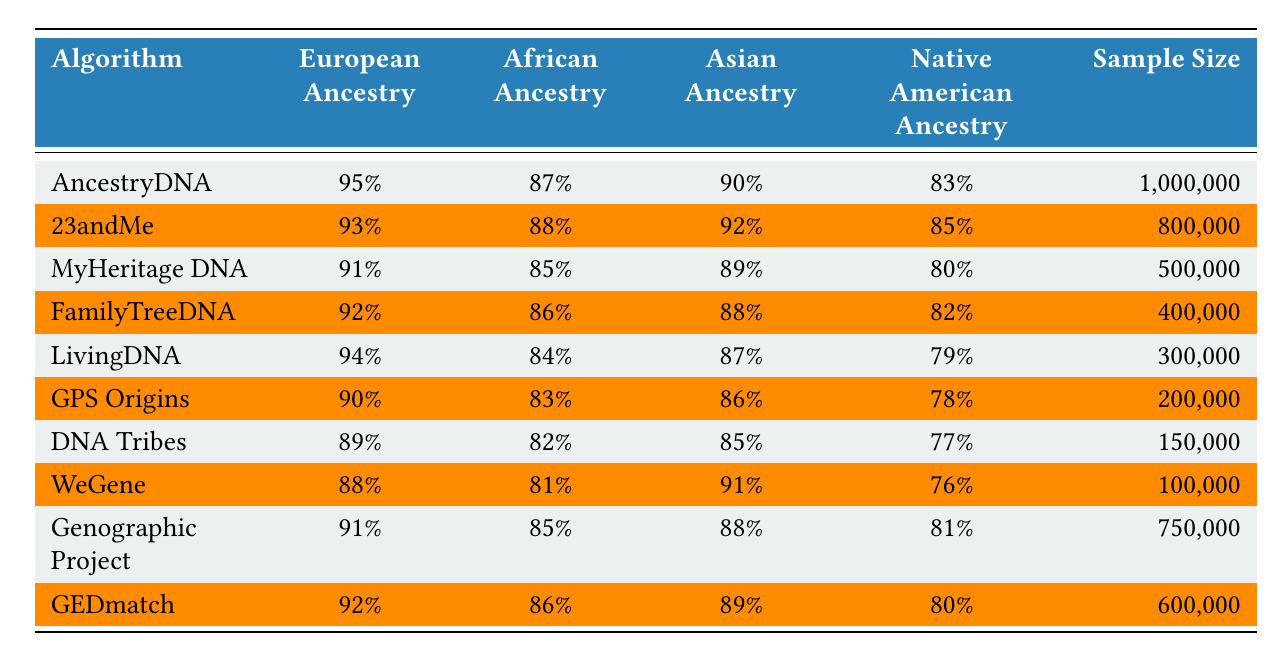What is the highest accuracy for European ancestry among the algorithms? The table lists the accuracy for European ancestry for each algorithm. The highest value is found under AncestryDNA, which has an accuracy of 95%.
Answer: 95% Which algorithm shows the lowest accuracy for African ancestry? By looking at the African ancestry accuracy values, DNA Tribes has the lowest accuracy at 82%.
Answer: 82% What is the average accuracy for Asian ancestry across all algorithms? To find the average accuracy for Asian ancestry, add all the percentages (90+92+89+88+87+86+85+91+88+89 = 885) and divide by the number of algorithms (10). 885 / 10 = 88.5%.
Answer: 88.5% Is the accuracy for Native American ancestry higher for 23andMe than for MyHeritage DNA? In the table, the accuracy for Native American ancestry for 23andMe is 85% and for MyHeritage DNA, it is 80%. Since 85% is greater than 80%, the statement is true.
Answer: Yes Which algorithm provides the highest accuracy for Native American ancestry, and what is that percentage? The table indicates that the highest accuracy for Native American ancestry is provided by 23andMe at 85%. To verify, check each algorithm's percentage and find that 85% is indeed the highest.
Answer: 85% What is the difference in accuracy for European ancestry between AncestryDNA and LivingDNA? To find the difference, subtract the accuracy of LivingDNA (94%) from AncestryDNA (95%). This results in a difference of 1%.
Answer: 1% Among the algorithms with a sample size over 500,000, which has the best accuracy for African ancestry, and what is that accuracy? Look at the algorithms with a sample size over 500,000, which include AncestryDNA (87%), 23andMe (88%), and Genographic Project (85%). The highest among these is 23andMe with 88%.
Answer: 88% Which algorithm has the least sample size, and what is that size? The table shows the sample sizes for each algorithm, with WeGene having the least sample size at 100,000.
Answer: 100,000 If you were to rank all the algorithms by their accuracy for European ancestry, what would be the rank of FamilyTreeDNA? The accuracy for European ancestry for FamilyTreeDNA is 92%. Ranking all algorithms, it would be the 4th best, as AncestryDNA (95%), LivingDNA (94%), and 23andMe (93%) are ahead.
Answer: 4th Is the accuracy for Asian ancestry consistently higher than that for Native American ancestry across all algorithms? Upon reviewing the Asian and Native American accuracy values, five algorithms (23andMe, MyHeritage DNA, FamilyTreeDNA, GPS Origins, and GEDmatch) have higher Asian accuracy than Native American, while five do not. Therefore, the consistency is false.
Answer: No 